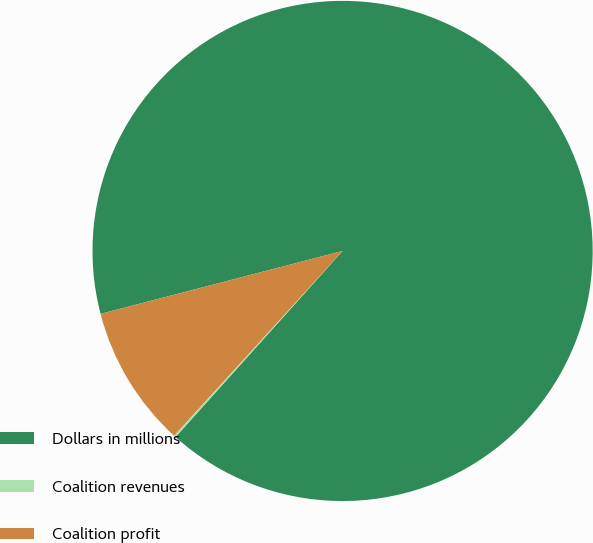Convert chart. <chart><loc_0><loc_0><loc_500><loc_500><pie_chart><fcel>Dollars in millions<fcel>Coalition revenues<fcel>Coalition profit<nl><fcel>90.69%<fcel>0.13%<fcel>9.18%<nl></chart> 